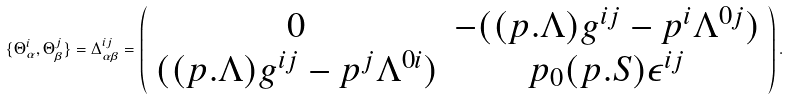Convert formula to latex. <formula><loc_0><loc_0><loc_500><loc_500>\{ \Theta ^ { i } _ { \alpha } , \Theta ^ { j } _ { \beta } \} = \Delta ^ { i j } _ { \alpha \beta } = \left ( \begin{array} { c c } 0 & - ( ( p . \Lambda ) g ^ { i j } - p ^ { i } \Lambda ^ { 0 j } ) \\ ( ( p . \Lambda ) g ^ { i j } - p ^ { j } \Lambda ^ { 0 i } ) & p _ { 0 } ( p . S ) \epsilon ^ { i j } \end{array} \right ) .</formula> 